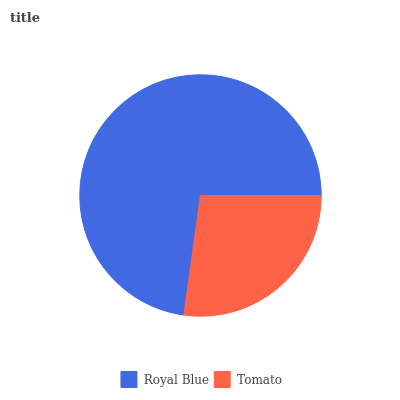Is Tomato the minimum?
Answer yes or no. Yes. Is Royal Blue the maximum?
Answer yes or no. Yes. Is Tomato the maximum?
Answer yes or no. No. Is Royal Blue greater than Tomato?
Answer yes or no. Yes. Is Tomato less than Royal Blue?
Answer yes or no. Yes. Is Tomato greater than Royal Blue?
Answer yes or no. No. Is Royal Blue less than Tomato?
Answer yes or no. No. Is Royal Blue the high median?
Answer yes or no. Yes. Is Tomato the low median?
Answer yes or no. Yes. Is Tomato the high median?
Answer yes or no. No. Is Royal Blue the low median?
Answer yes or no. No. 